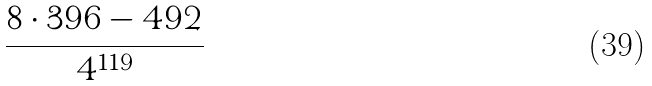Convert formula to latex. <formula><loc_0><loc_0><loc_500><loc_500>\frac { 8 \cdot 3 9 6 - 4 9 2 } { 4 ^ { 1 1 9 } }</formula> 